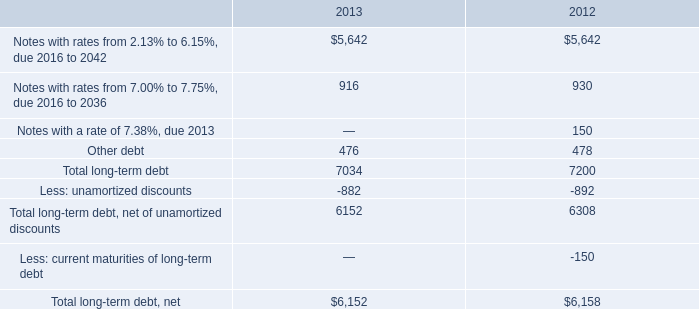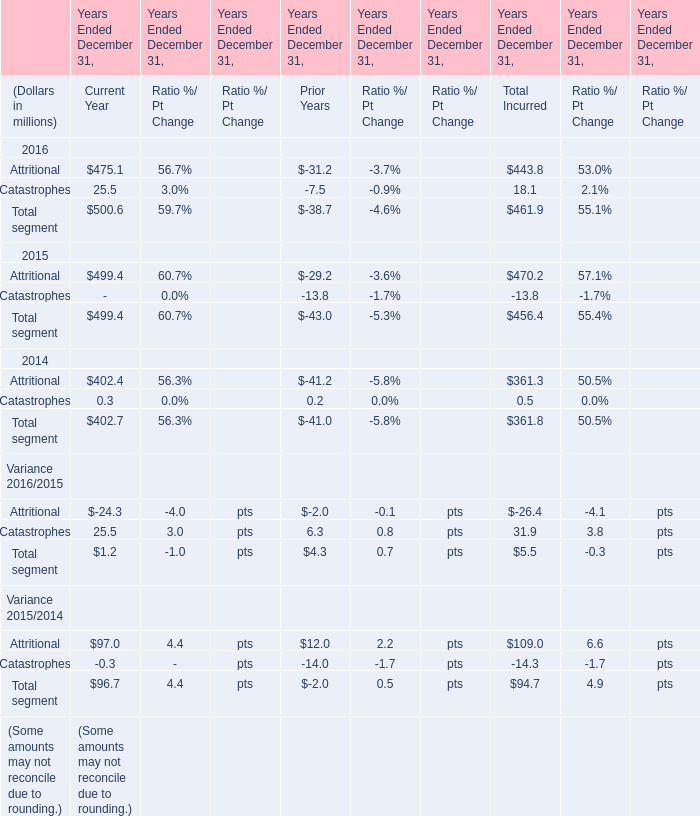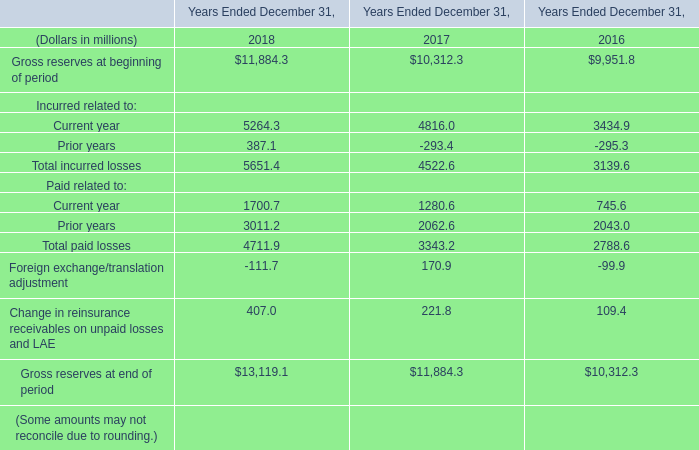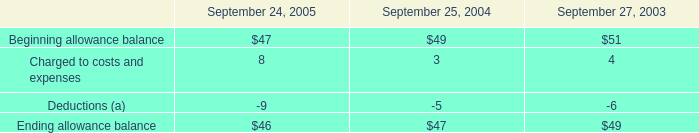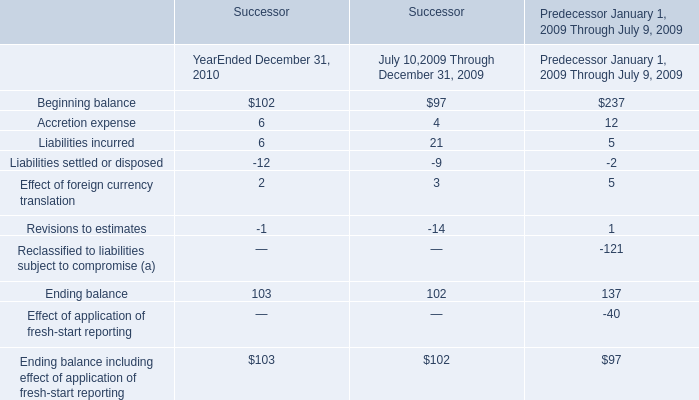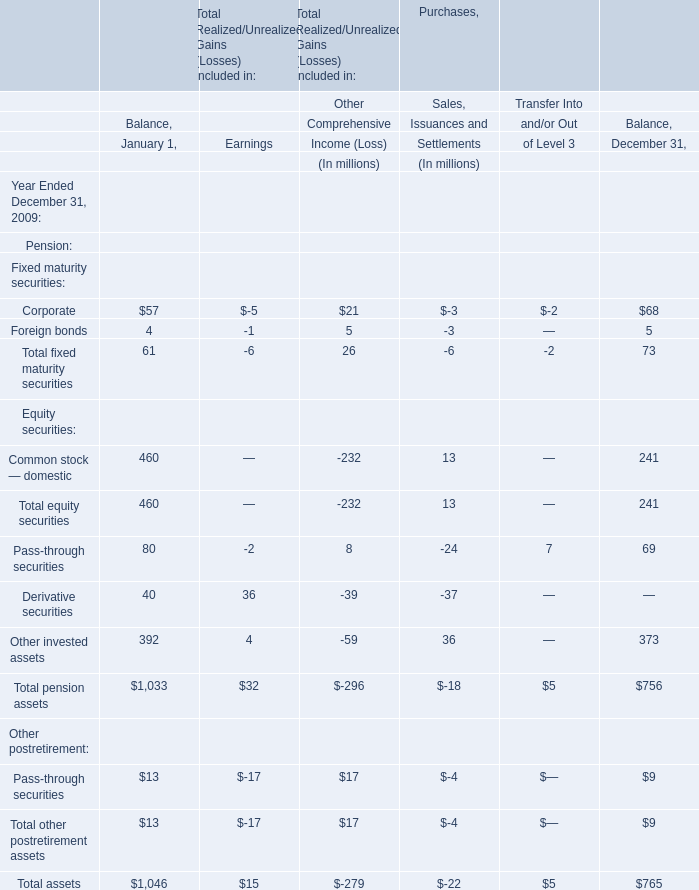What is the sum of Corporate, Foreign bonds and Total fixed maturity securities in 2009? (in million) 
Computations: ((68 + 5) + 73)
Answer: 146.0. 